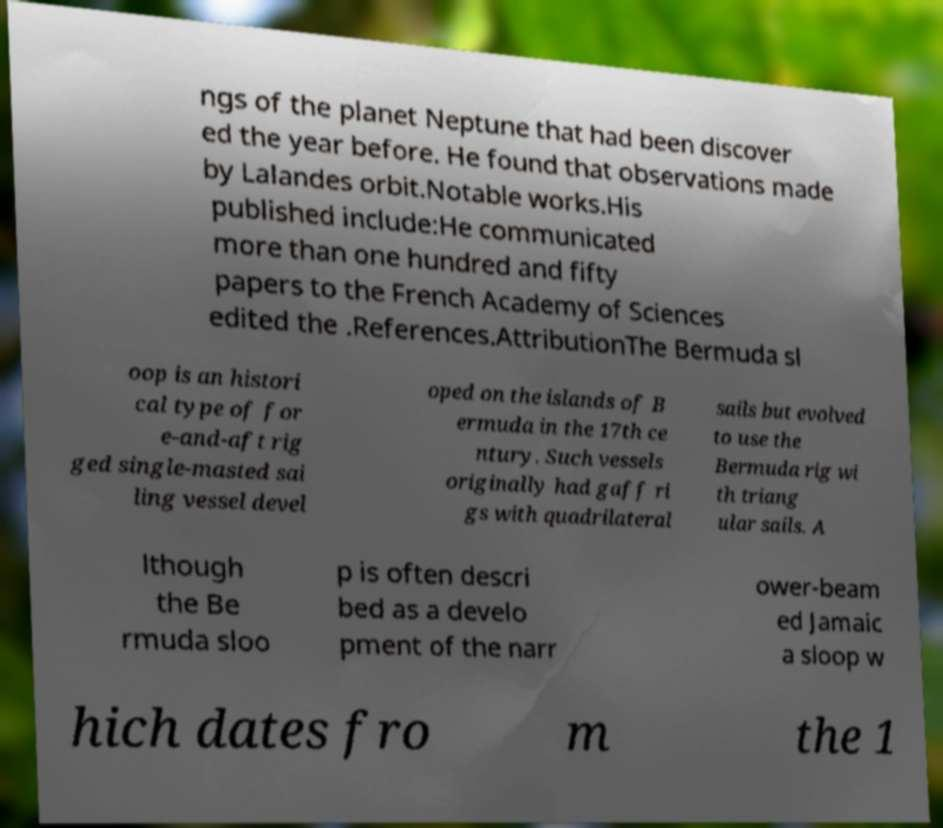What messages or text are displayed in this image? I need them in a readable, typed format. ngs of the planet Neptune that had been discover ed the year before. He found that observations made by Lalandes orbit.Notable works.His published include:He communicated more than one hundred and fifty papers to the French Academy of Sciences edited the .References.AttributionThe Bermuda sl oop is an histori cal type of for e-and-aft rig ged single-masted sai ling vessel devel oped on the islands of B ermuda in the 17th ce ntury. Such vessels originally had gaff ri gs with quadrilateral sails but evolved to use the Bermuda rig wi th triang ular sails. A lthough the Be rmuda sloo p is often descri bed as a develo pment of the narr ower-beam ed Jamaic a sloop w hich dates fro m the 1 